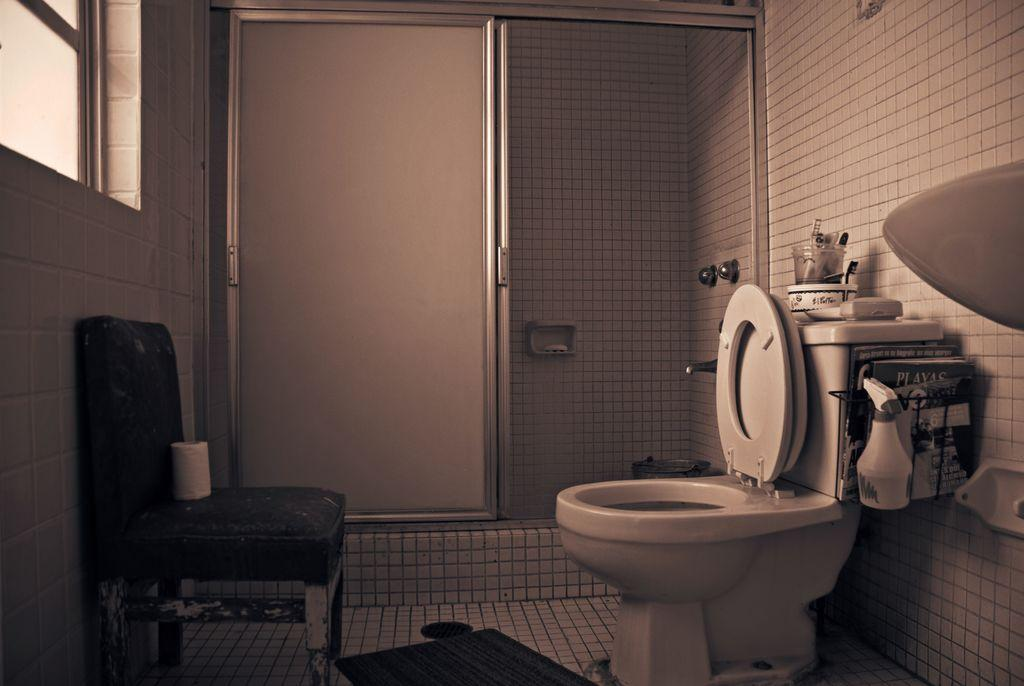What type of entryway is present in the image? There is a door in the image. What fixture is present for personal hygiene purposes? There is a toilet in the image. What type of furniture is present in the image? There is a chair in the image. What allows natural light and air to enter the room in the image? There is a window in the image. What type of badge is visible on the chair in the image? There is no badge present in the image. How comfortable is the jail cell in the image? There is no jail cell present in the image, so it cannot be determined how comfortable it might be. 